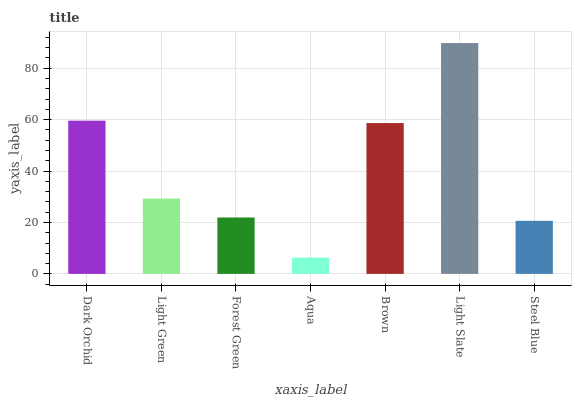Is Aqua the minimum?
Answer yes or no. Yes. Is Light Slate the maximum?
Answer yes or no. Yes. Is Light Green the minimum?
Answer yes or no. No. Is Light Green the maximum?
Answer yes or no. No. Is Dark Orchid greater than Light Green?
Answer yes or no. Yes. Is Light Green less than Dark Orchid?
Answer yes or no. Yes. Is Light Green greater than Dark Orchid?
Answer yes or no. No. Is Dark Orchid less than Light Green?
Answer yes or no. No. Is Light Green the high median?
Answer yes or no. Yes. Is Light Green the low median?
Answer yes or no. Yes. Is Steel Blue the high median?
Answer yes or no. No. Is Steel Blue the low median?
Answer yes or no. No. 